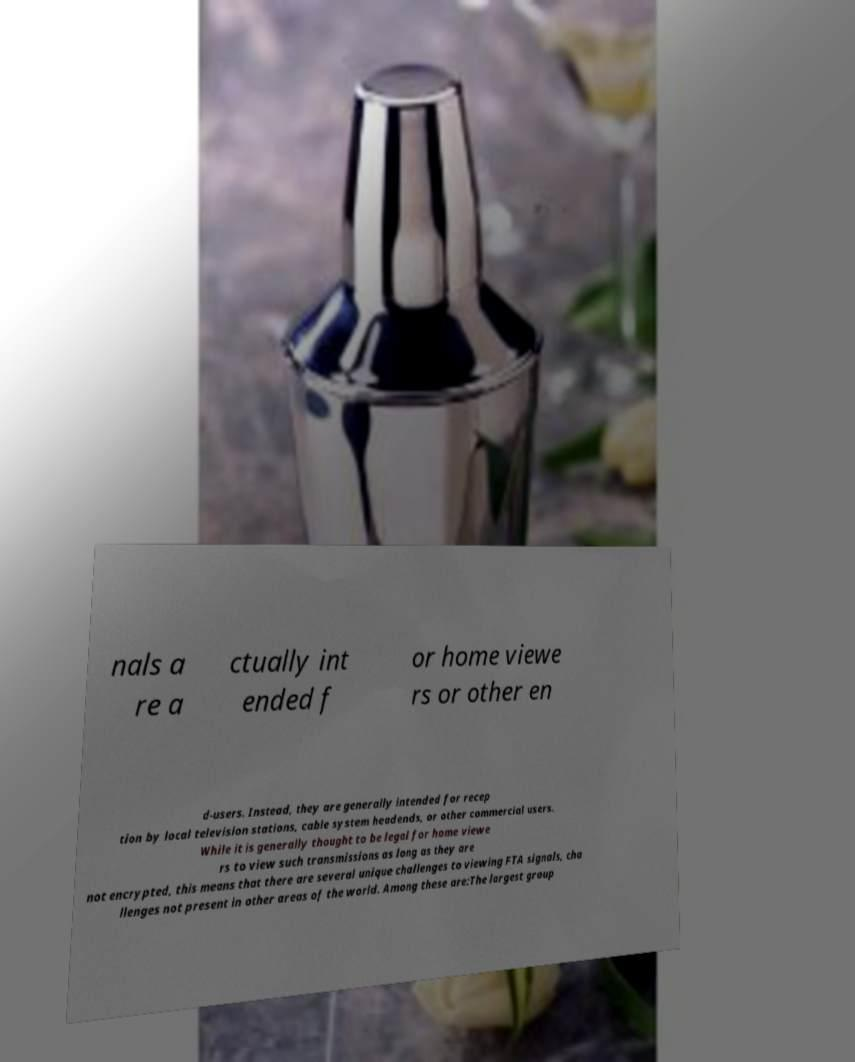For documentation purposes, I need the text within this image transcribed. Could you provide that? nals a re a ctually int ended f or home viewe rs or other en d-users. Instead, they are generally intended for recep tion by local television stations, cable system headends, or other commercial users. While it is generally thought to be legal for home viewe rs to view such transmissions as long as they are not encrypted, this means that there are several unique challenges to viewing FTA signals, cha llenges not present in other areas of the world. Among these are:The largest group 